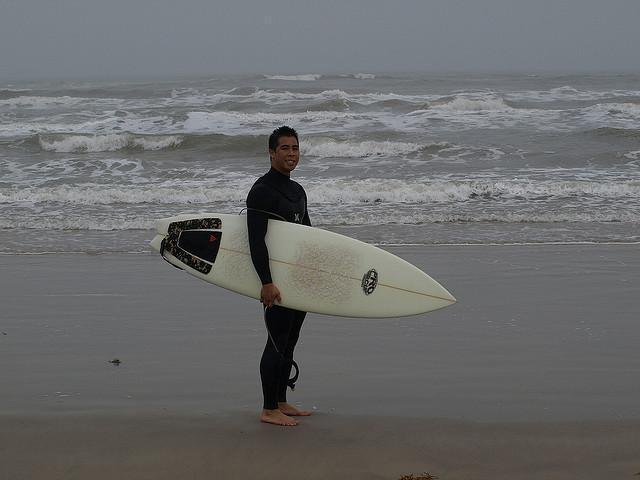How many people are in the picture?
Give a very brief answer. 1. How many surfers are shown?
Give a very brief answer. 1. 